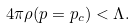Convert formula to latex. <formula><loc_0><loc_0><loc_500><loc_500>4 \pi \rho ( p = p _ { c } ) < \Lambda .</formula> 